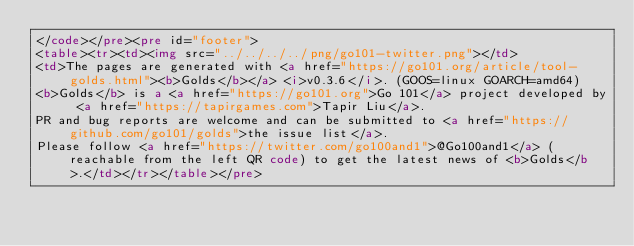Convert code to text. <code><loc_0><loc_0><loc_500><loc_500><_HTML_></code></pre><pre id="footer">
<table><tr><td><img src="../../../../png/go101-twitter.png"></td>
<td>The pages are generated with <a href="https://go101.org/article/tool-golds.html"><b>Golds</b></a> <i>v0.3.6</i>. (GOOS=linux GOARCH=amd64)
<b>Golds</b> is a <a href="https://go101.org">Go 101</a> project developed by <a href="https://tapirgames.com">Tapir Liu</a>.
PR and bug reports are welcome and can be submitted to <a href="https://github.com/go101/golds">the issue list</a>.
Please follow <a href="https://twitter.com/go100and1">@Go100and1</a> (reachable from the left QR code) to get the latest news of <b>Golds</b>.</td></tr></table></pre></code> 